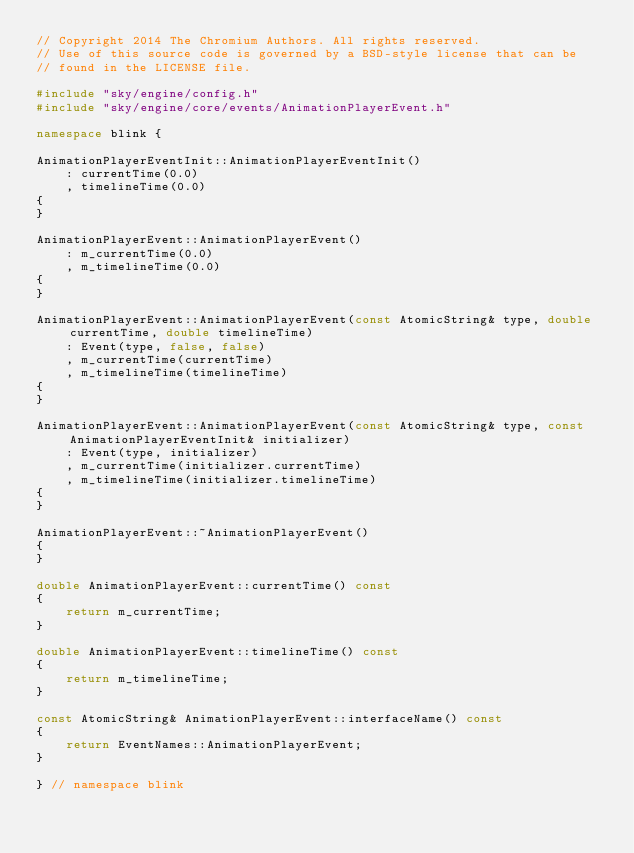<code> <loc_0><loc_0><loc_500><loc_500><_C++_>// Copyright 2014 The Chromium Authors. All rights reserved.
// Use of this source code is governed by a BSD-style license that can be
// found in the LICENSE file.

#include "sky/engine/config.h"
#include "sky/engine/core/events/AnimationPlayerEvent.h"

namespace blink {

AnimationPlayerEventInit::AnimationPlayerEventInit()
    : currentTime(0.0)
    , timelineTime(0.0)
{
}

AnimationPlayerEvent::AnimationPlayerEvent()
    : m_currentTime(0.0)
    , m_timelineTime(0.0)
{
}

AnimationPlayerEvent::AnimationPlayerEvent(const AtomicString& type, double currentTime, double timelineTime)
    : Event(type, false, false)
    , m_currentTime(currentTime)
    , m_timelineTime(timelineTime)
{
}

AnimationPlayerEvent::AnimationPlayerEvent(const AtomicString& type, const AnimationPlayerEventInit& initializer)
    : Event(type, initializer)
    , m_currentTime(initializer.currentTime)
    , m_timelineTime(initializer.timelineTime)
{
}

AnimationPlayerEvent::~AnimationPlayerEvent()
{
}

double AnimationPlayerEvent::currentTime() const
{
    return m_currentTime;
}

double AnimationPlayerEvent::timelineTime() const
{
    return m_timelineTime;
}

const AtomicString& AnimationPlayerEvent::interfaceName() const
{
    return EventNames::AnimationPlayerEvent;
}

} // namespace blink
</code> 